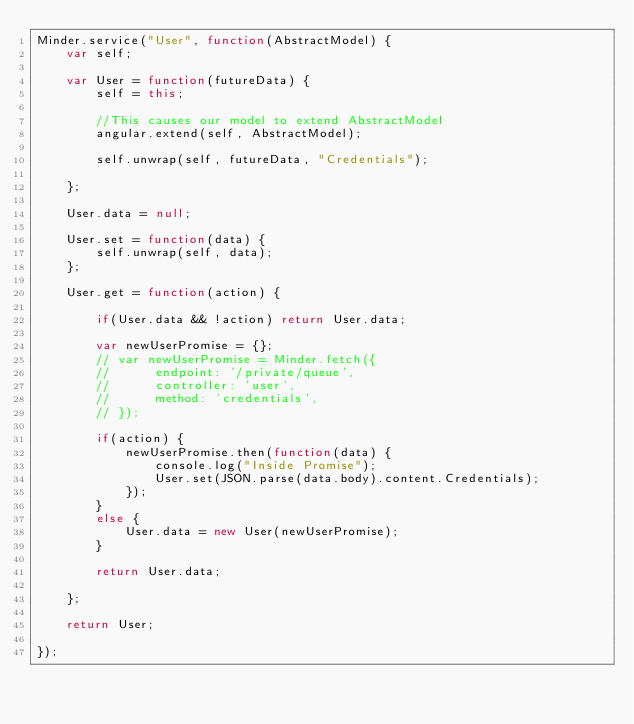Convert code to text. <code><loc_0><loc_0><loc_500><loc_500><_JavaScript_>Minder.service("User", function(AbstractModel) {
	var self;

	var User = function(futureData) {
		self = this;

		//This causes our model to extend AbstractModel
		angular.extend(self, AbstractModel);
		
		self.unwrap(self, futureData, "Credentials");
		
	};

	User.data = null;
	
	User.set = function(data) {
		self.unwrap(self, data);
	};

	User.get = function(action) {

		if(User.data && !action) return User.data;

		var newUserPromise = {};
		// var newUserPromise = Minder.fetch({
		// 		endpoint: '/private/queue', 
		// 		controller: 'user', 
		// 		method: 'credentials',
		// });

		if(action) {
			newUserPromise.then(function(data) {
				console.log("Inside Promise");
				User.set(JSON.parse(data.body).content.Credentials);
			});
		}
		else {
			User.data = new User(newUserPromise);	
		}

		return User.data;
	
	};
		
	return User;
	
});
</code> 